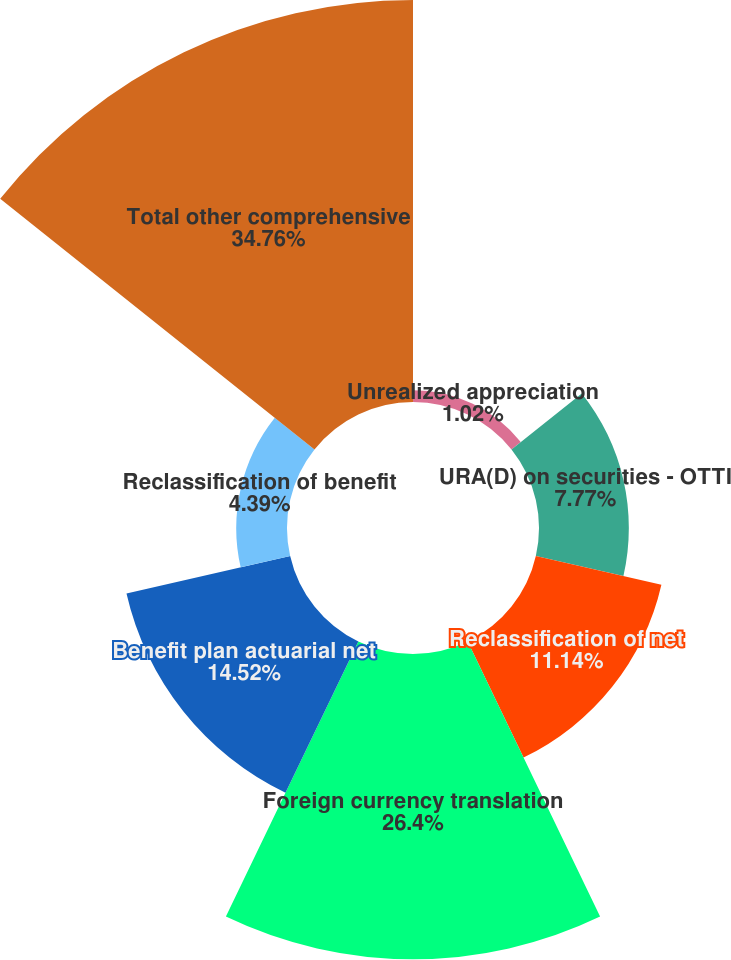Convert chart to OTSL. <chart><loc_0><loc_0><loc_500><loc_500><pie_chart><fcel>Unrealized appreciation<fcel>URA(D) on securities - OTTI<fcel>Reclassification of net<fcel>Foreign currency translation<fcel>Benefit plan actuarial net<fcel>Reclassification of benefit<fcel>Total other comprehensive<nl><fcel>1.02%<fcel>7.77%<fcel>11.14%<fcel>26.4%<fcel>14.52%<fcel>4.39%<fcel>34.77%<nl></chart> 